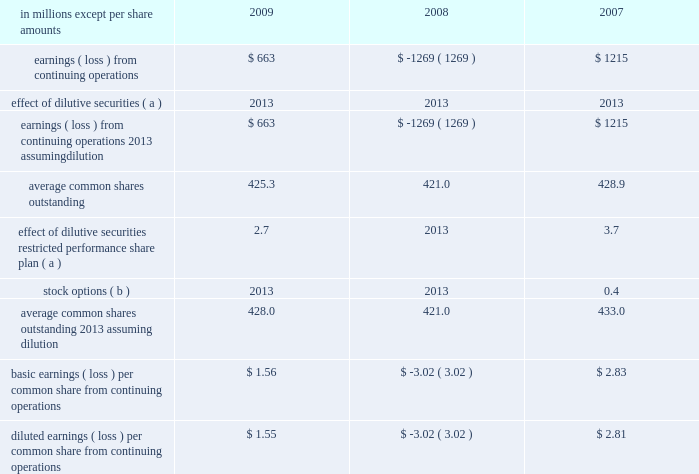In april 2009 , the fasb issued additional guidance under asc 820 which provides guidance on estimat- ing the fair value of an asset or liability ( financial or nonfinancial ) when the volume and level of activity for the asset or liability have significantly decreased , and on identifying transactions that are not orderly .
The application of the requirements of this guidance did not have a material effect on the accompanying consolidated financial statements .
In august 2009 , the fasb issued asu 2009-05 , 201cmeasuring liabilities at fair value , 201d which further amends asc 820 by providing clarification for cir- cumstances in which a quoted price in an active market for the identical liability is not available .
The company included the disclosures required by this guidance in the accompanying consolidated financial statements .
Accounting for uncertainty in income taxes in june 2006 , the fasb issued guidance under asc 740 , 201cincome taxes 201d ( formerly fin 48 ) .
This guid- ance prescribes a recognition threshold and measurement attribute for the financial statement recognition and measurement of a tax position taken or expected to be taken in tax returns .
Specifically , the financial statement effects of a tax position may be recognized only when it is determined that it is 201cmore likely than not 201d that , based on its technical merits , the tax position will be sustained upon examination by the relevant tax authority .
The amount recognized shall be measured as the largest amount of tax benefits that exceed a 50% ( 50 % ) probability of being recognized .
This guidance also expands income tax disclosure requirements .
International paper applied the provisions of this guidance begin- ning in the first quarter of 2007 .
The adoption of this guidance resulted in a charge to the beginning bal- ance of retained earnings of $ 94 million at the date of adoption .
Note 3 industry segment information financial information by industry segment and geo- graphic area for 2009 , 2008 and 2007 is presented on pages 47 and 48 .
Effective january 1 , 2008 , the company changed its method of allocating corpo- rate overhead expenses to its business segments to increase the expense amounts allocated to these businesses in reports reviewed by its chief executive officer to facilitate performance comparisons with other companies .
Accordingly , the company has revised its presentation of industry segment operat- ing profit to reflect this change in allocation method , and has adjusted all comparative prior period information on this basis .
Note 4 earnings per share attributable to international paper company common shareholders basic earnings per common share from continuing operations are computed by dividing earnings from continuing operations by the weighted average number of common shares outstanding .
Diluted earnings per common share from continuing oper- ations are computed assuming that all potentially dilutive securities , including 201cin-the-money 201d stock options , were converted into common shares at the beginning of each year .
In addition , the computation of diluted earnings per share reflects the inclusion of contingently convertible securities in periods when dilutive .
A reconciliation of the amounts included in the computation of basic earnings per common share from continuing operations , and diluted earnings per common share from continuing operations is as fol- in millions except per share amounts 2009 2008 2007 .
Average common shares outstanding 2013 assuming dilution 428.0 421.0 433.0 basic earnings ( loss ) per common share from continuing operations $ 1.56 $ ( 3.02 ) $ 2.83 diluted earnings ( loss ) per common share from continuing operations $ 1.55 $ ( 3.02 ) $ 2.81 ( a ) securities are not included in the table in periods when anti- dilutive .
( b ) options to purchase 22.2 million , 25.1 million and 17.5 million shares for the years ended december 31 , 2009 , 2008 and 2007 , respectively , were not included in the computation of diluted common shares outstanding because their exercise price exceeded the average market price of the company 2019s common stock for each respective reporting date .
Note 5 restructuring and other charges this footnote discusses restructuring and other charges recorded for each of the three years included in the period ended december 31 , 2009 .
It .
What was the ratio of the common shares whose exercise price exceeded the average market price of the company 2019s common stock for each respective reporting date in 2008 to 2007? 
Computations: (25.1 / 17.5)
Answer: 1.43429. 